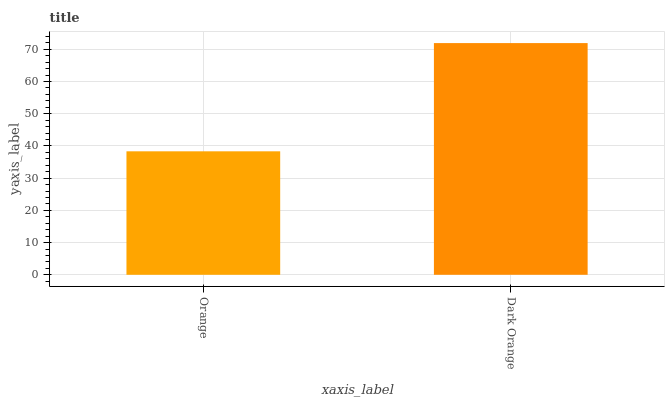Is Orange the minimum?
Answer yes or no. Yes. Is Dark Orange the maximum?
Answer yes or no. Yes. Is Dark Orange the minimum?
Answer yes or no. No. Is Dark Orange greater than Orange?
Answer yes or no. Yes. Is Orange less than Dark Orange?
Answer yes or no. Yes. Is Orange greater than Dark Orange?
Answer yes or no. No. Is Dark Orange less than Orange?
Answer yes or no. No. Is Dark Orange the high median?
Answer yes or no. Yes. Is Orange the low median?
Answer yes or no. Yes. Is Orange the high median?
Answer yes or no. No. Is Dark Orange the low median?
Answer yes or no. No. 